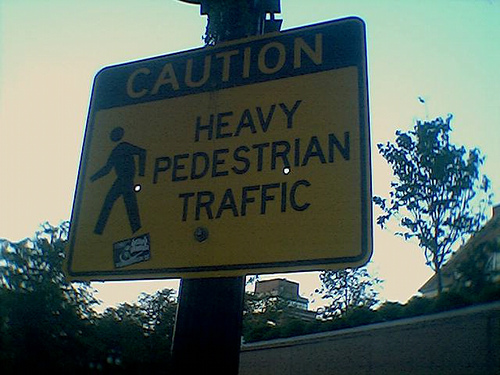Identify the text contained in this image. CAUTION HEAVY PEDESTRIAN TRAFFIC 